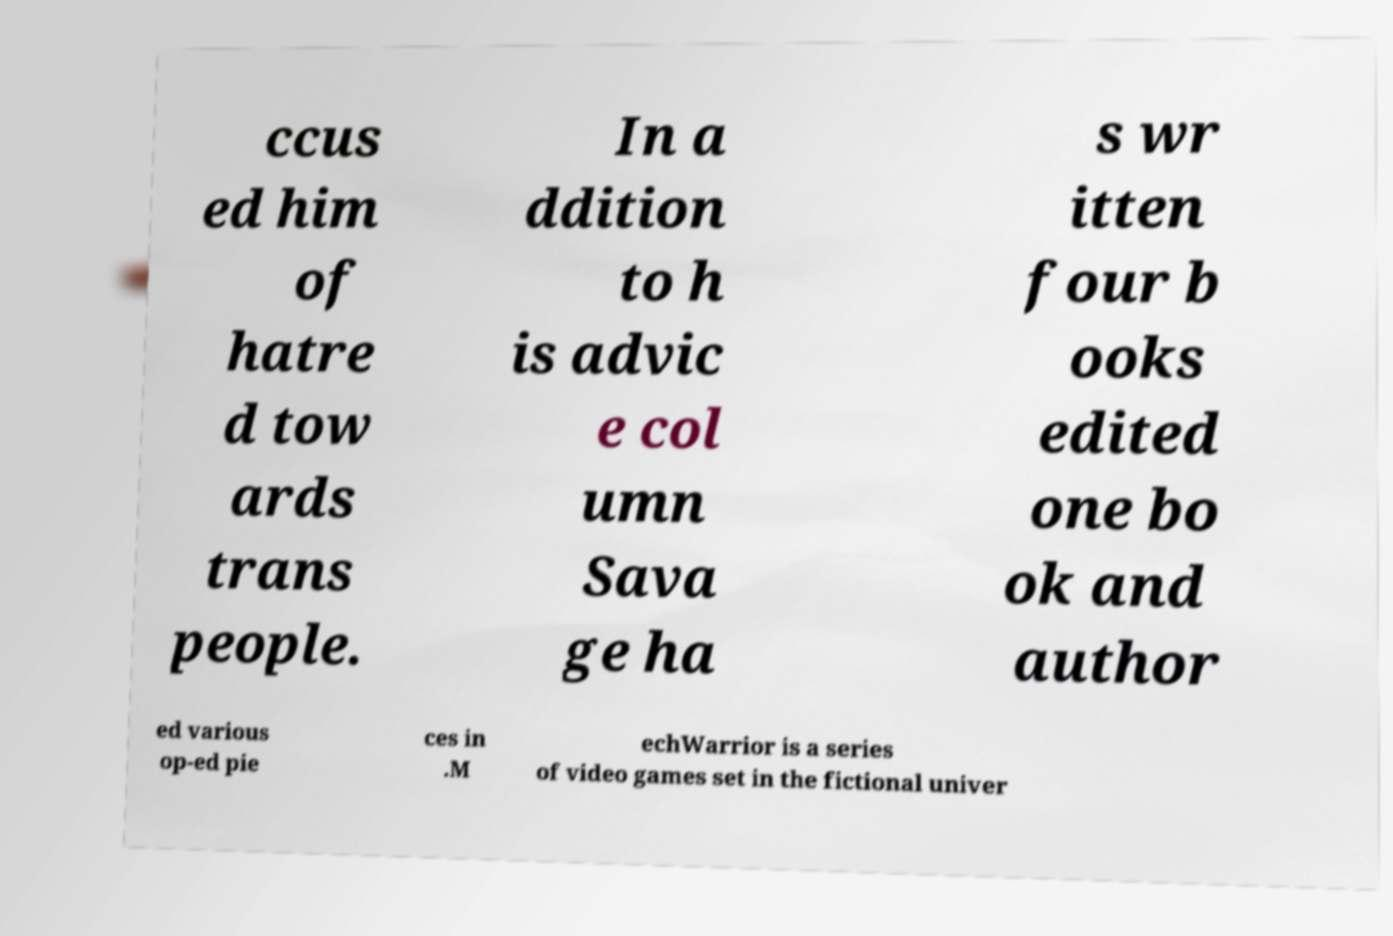Could you extract and type out the text from this image? ccus ed him of hatre d tow ards trans people. In a ddition to h is advic e col umn Sava ge ha s wr itten four b ooks edited one bo ok and author ed various op-ed pie ces in .M echWarrior is a series of video games set in the fictional univer 